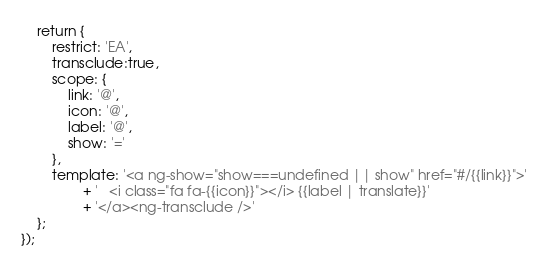Convert code to text. <code><loc_0><loc_0><loc_500><loc_500><_JavaScript_>	return {
		restrict: 'EA',
		transclude:true,
		scope: {
			link: '@',
			icon: '@',
			label: '@',
			show: '='
		},
		template: '<a ng-show="show===undefined || show" href="#/{{link}}">'
				+ '	<i class="fa fa-{{icon}}"></i> {{label | translate}}'
				+ '</a><ng-transclude />'
	};
});</code> 